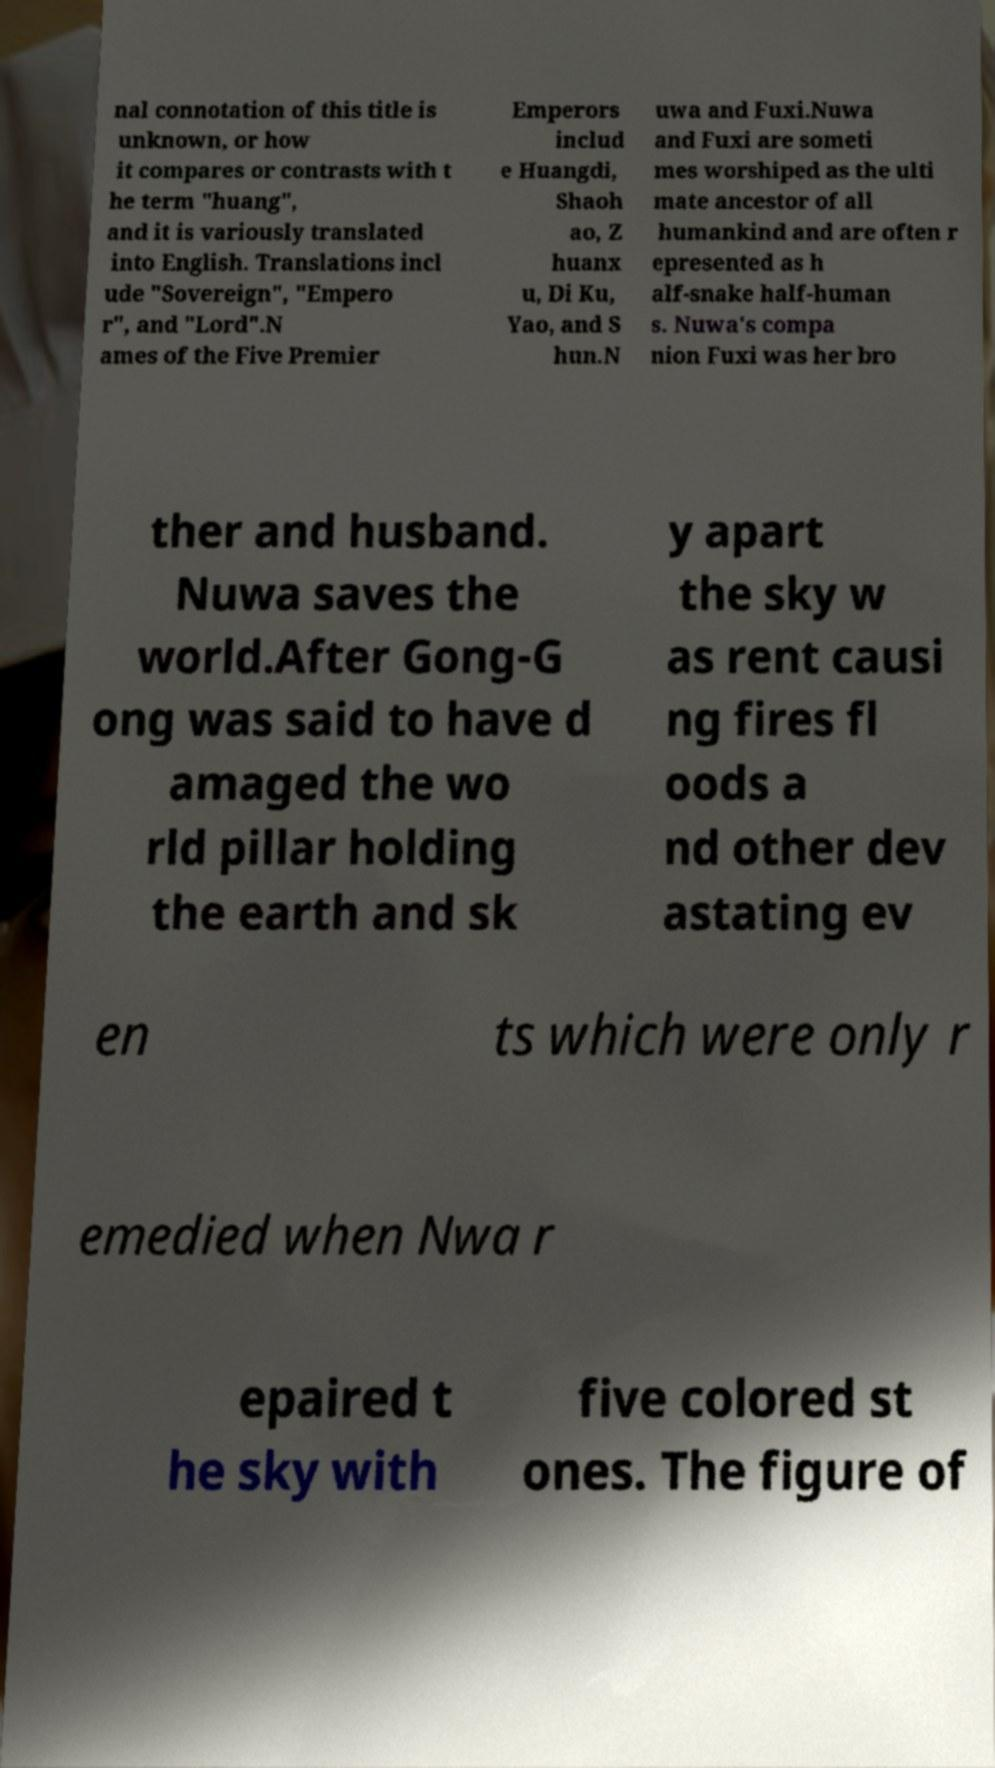There's text embedded in this image that I need extracted. Can you transcribe it verbatim? nal connotation of this title is unknown, or how it compares or contrasts with t he term "huang", and it is variously translated into English. Translations incl ude "Sovereign", "Empero r", and "Lord".N ames of the Five Premier Emperors includ e Huangdi, Shaoh ao, Z huanx u, Di Ku, Yao, and S hun.N uwa and Fuxi.Nuwa and Fuxi are someti mes worshiped as the ulti mate ancestor of all humankind and are often r epresented as h alf-snake half-human s. Nuwa's compa nion Fuxi was her bro ther and husband. Nuwa saves the world.After Gong-G ong was said to have d amaged the wo rld pillar holding the earth and sk y apart the sky w as rent causi ng fires fl oods a nd other dev astating ev en ts which were only r emedied when Nwa r epaired t he sky with five colored st ones. The figure of 